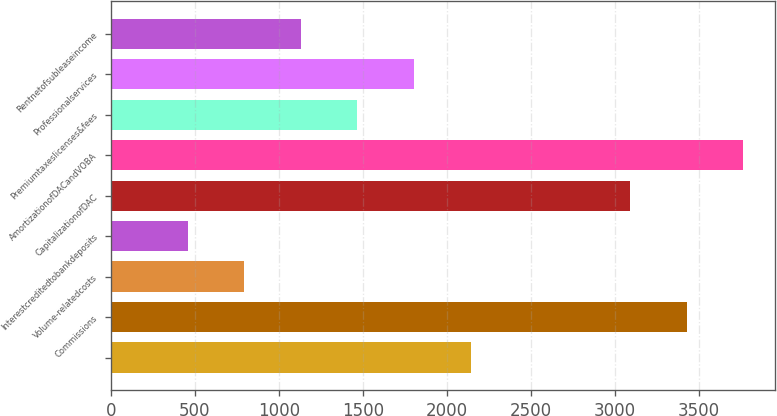<chart> <loc_0><loc_0><loc_500><loc_500><bar_chart><ecel><fcel>Commissions<fcel>Volume-relatedcosts<fcel>Interestcreditedtobankdeposits<fcel>CapitalizationofDAC<fcel>AmortizationofDACandVOBA<fcel>Premiumtaxeslicenses&fees<fcel>Professionalservices<fcel>Rentnetofsubleaseincome<nl><fcel>2141.4<fcel>3428.9<fcel>793.8<fcel>456.9<fcel>3092<fcel>3765.8<fcel>1467.6<fcel>1804.5<fcel>1130.7<nl></chart> 